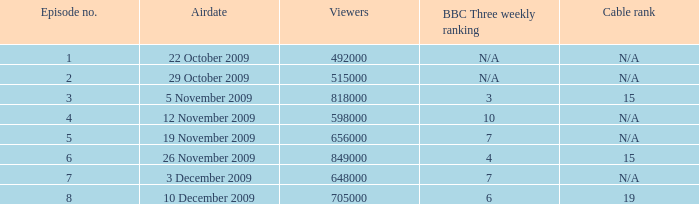What is the cable rank for the airdate of 10 december 2009? 19.0. 